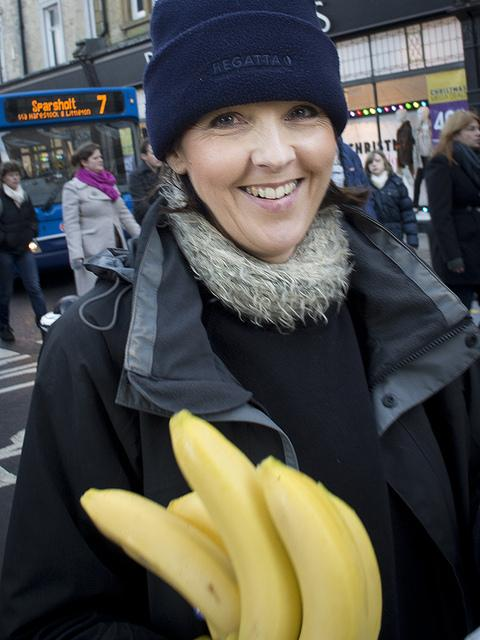The store behind the bus is having a sale due to which major event?

Choices:
A) boxing day
B) halloween
C) labor day
D) christmas christmas 